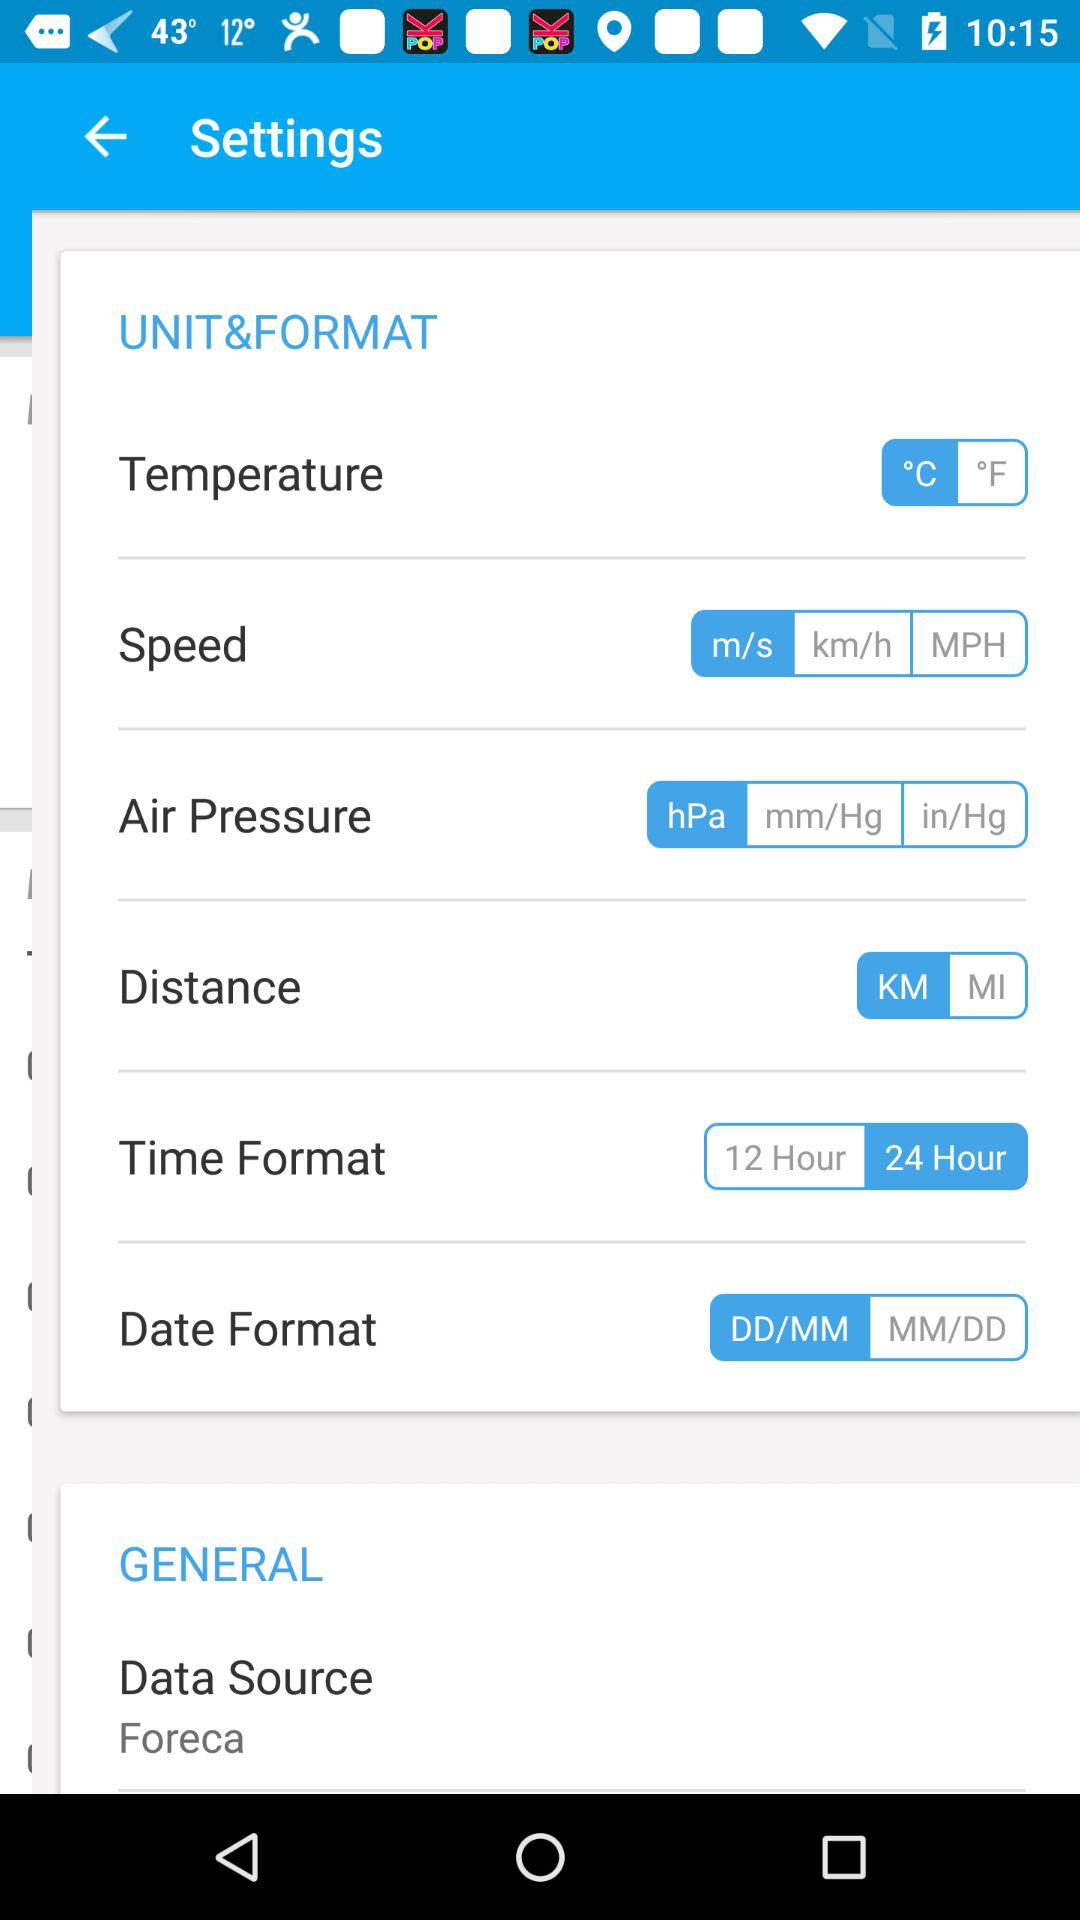Which air pressure unit is selected? The selected air pressure unit is hPa. 